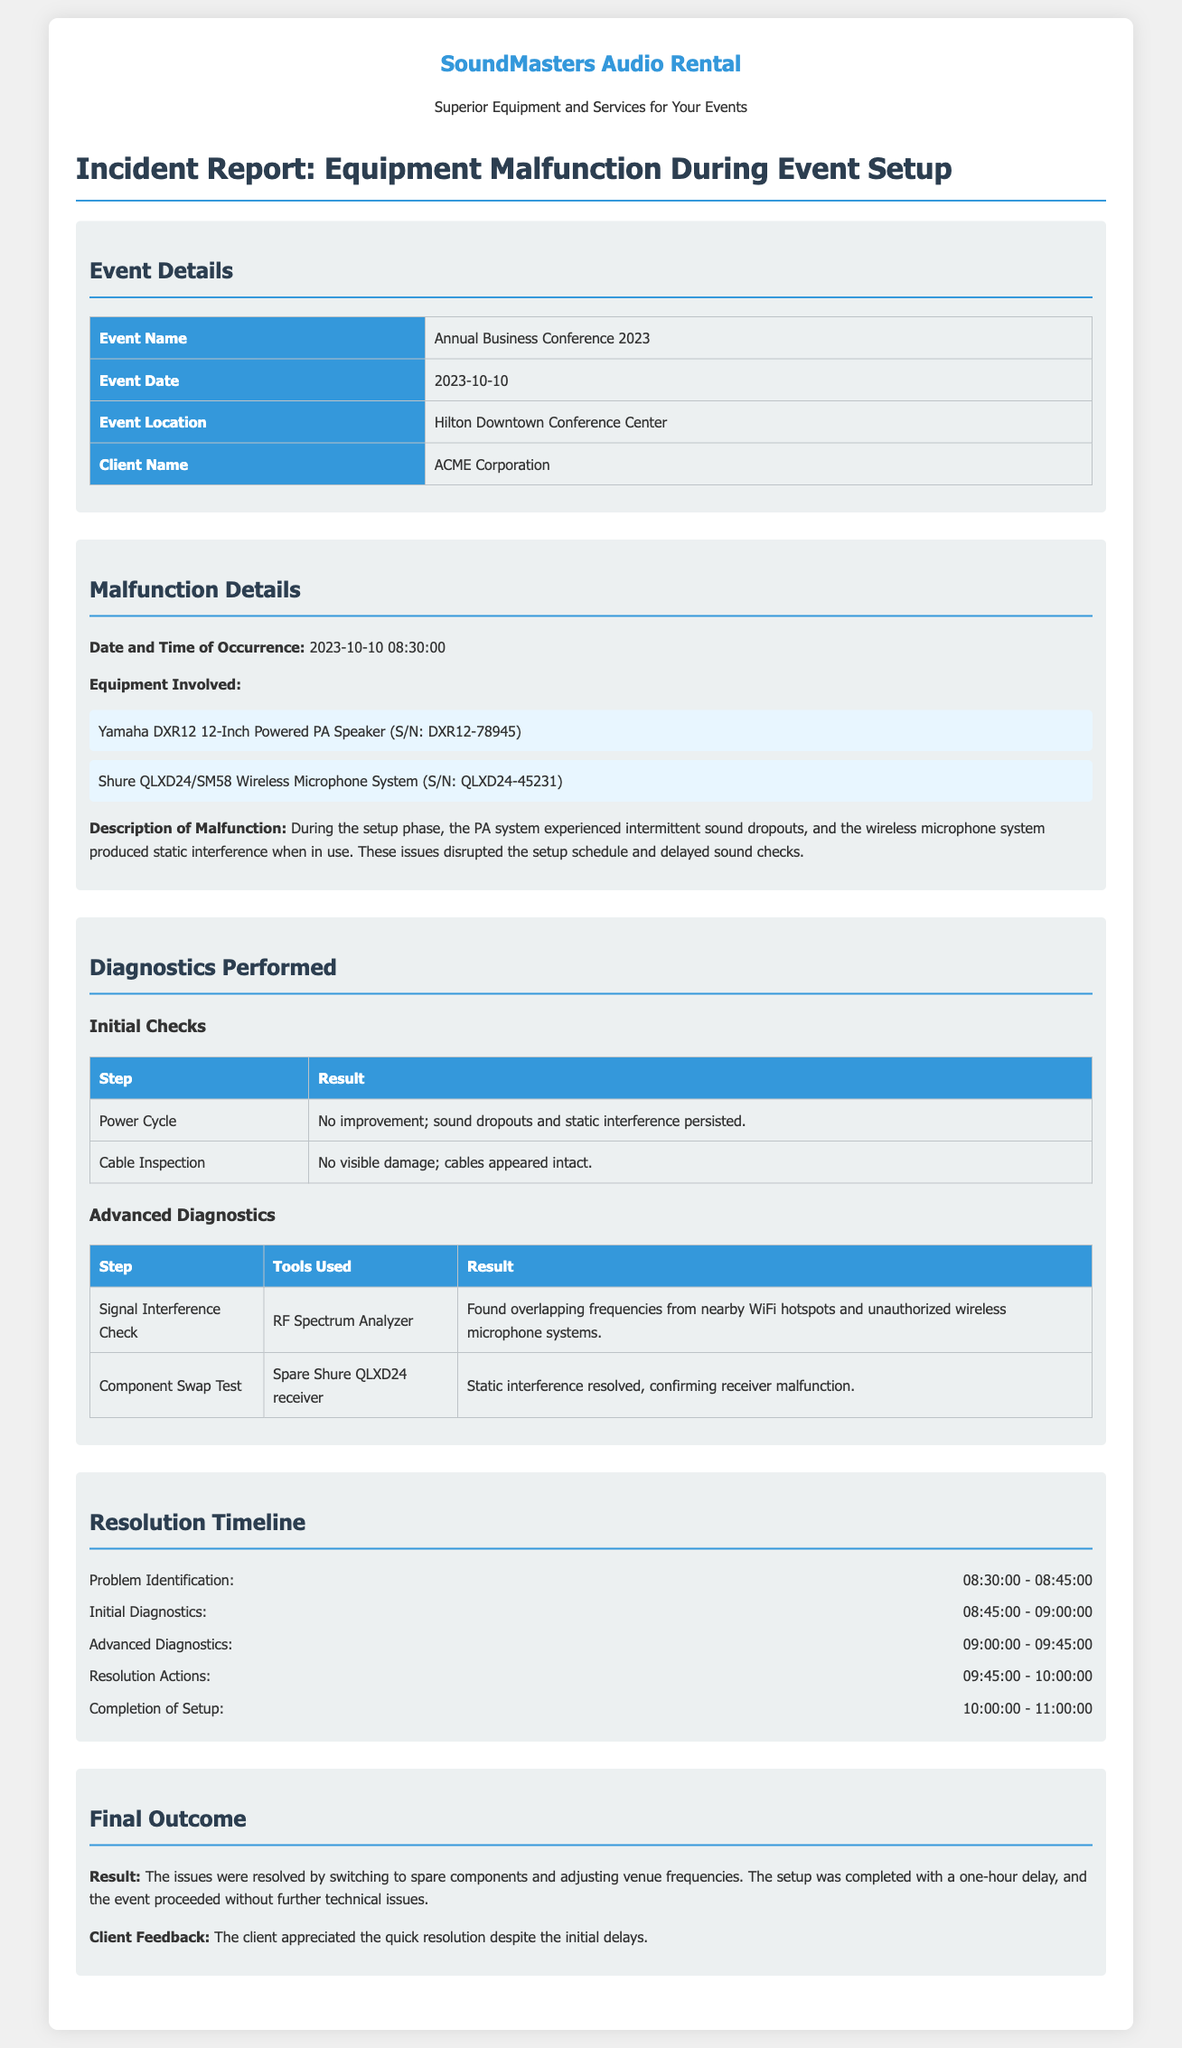what is the event name? The event name is listed in the document under Event Details.
Answer: Annual Business Conference 2023 what equipment experienced malfunction? The document provides a list of equipment involved in the malfunction.
Answer: Yamaha DXR12 12-Inch Powered PA Speaker, Shure QLXD24/SM58 Wireless Microphone System what time did problem identification begin? The resolution timeline outlines the start time for problem identification.
Answer: 08:30:00 what was found during the signal interference check? The diagnostics performed detail the results of the signal interference check.
Answer: Overlapping frequencies from nearby WiFi hotspots and unauthorized wireless microphone systems how long was the delay in the setup completion? The final outcome summarizes the resolution time and delays.
Answer: One hour who was the client for the event? The client's name is mentioned in the Event Details section.
Answer: ACME Corporation what tool was used during advanced diagnostics? The advanced diagnostics section specifies the tools used.
Answer: RF Spectrum Analyzer what was the client’s feedback after resolution? The final outcome section shares feedback received from the client.
Answer: Appreciated the quick resolution despite the initial delays 